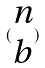<formula> <loc_0><loc_0><loc_500><loc_500>( \begin{matrix} n \\ b \end{matrix} )</formula> 